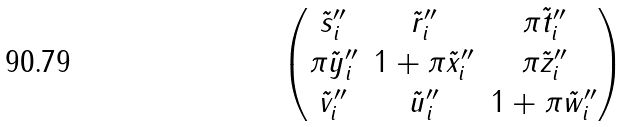Convert formula to latex. <formula><loc_0><loc_0><loc_500><loc_500>\begin{pmatrix} \tilde { s } _ { i } ^ { \prime \prime } & \tilde { r } _ { i } ^ { \prime \prime } & \pi \tilde { t } _ { i } ^ { \prime \prime } \\ \pi \tilde { y } _ { i } ^ { \prime \prime } & 1 + \pi \tilde { x } _ { i } ^ { \prime \prime } & \pi \tilde { z } _ { i } ^ { \prime \prime } \\ \tilde { v } _ { i } ^ { \prime \prime } & \tilde { u } _ { i } ^ { \prime \prime } & 1 + \pi \tilde { w } _ { i } ^ { \prime \prime } \end{pmatrix}</formula> 